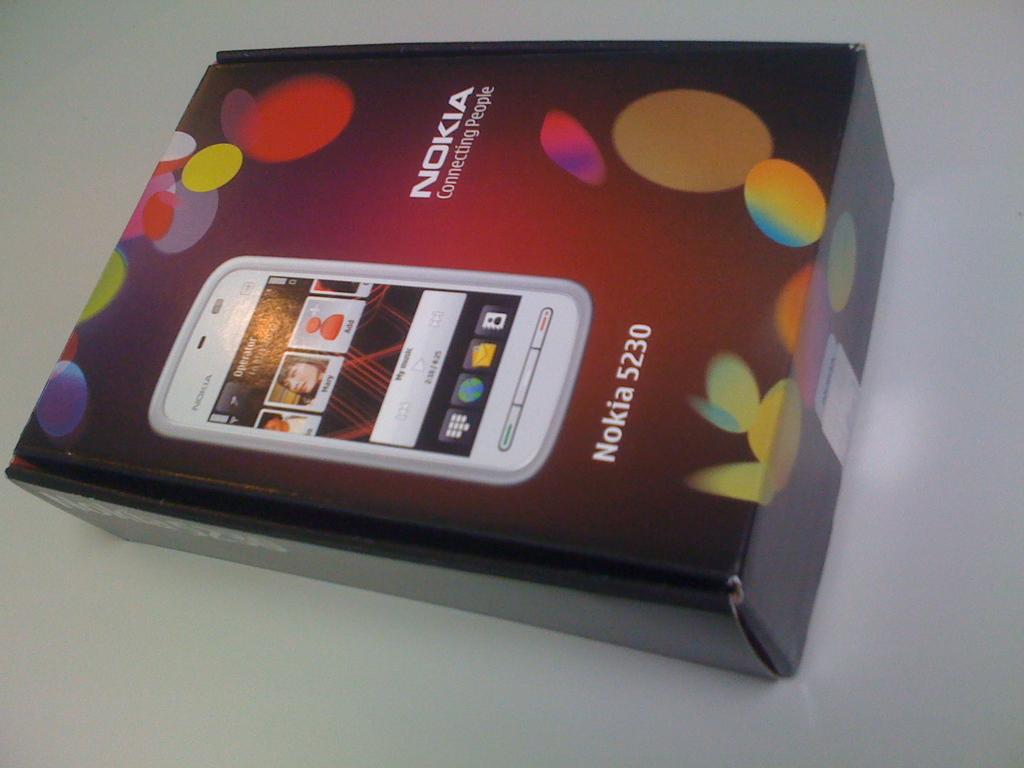What brand of phone is on the box?
Your response must be concise. Nokia. What model of brand phone is shown?
Offer a terse response. Nokia. 